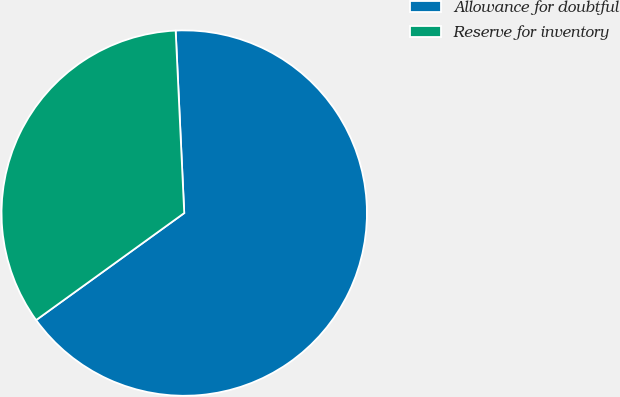Convert chart to OTSL. <chart><loc_0><loc_0><loc_500><loc_500><pie_chart><fcel>Allowance for doubtful<fcel>Reserve for inventory<nl><fcel>65.79%<fcel>34.21%<nl></chart> 